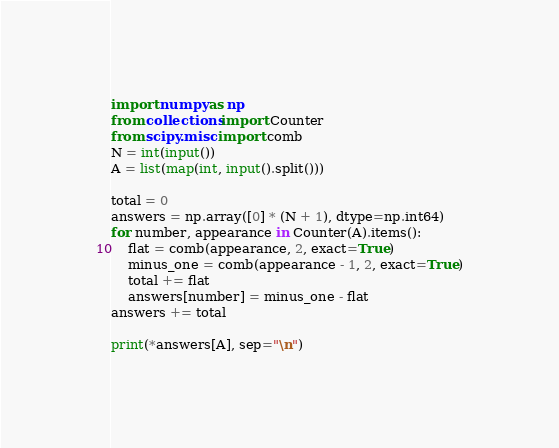Convert code to text. <code><loc_0><loc_0><loc_500><loc_500><_Python_>import numpy as np
from collections import Counter
from scipy.misc import comb
N = int(input())
A = list(map(int, input().split()))

total = 0
answers = np.array([0] * (N + 1), dtype=np.int64)
for number, appearance in Counter(A).items():
    flat = comb(appearance, 2, exact=True)
    minus_one = comb(appearance - 1, 2, exact=True)
    total += flat
    answers[number] = minus_one - flat
answers += total

print(*answers[A], sep="\n")
</code> 